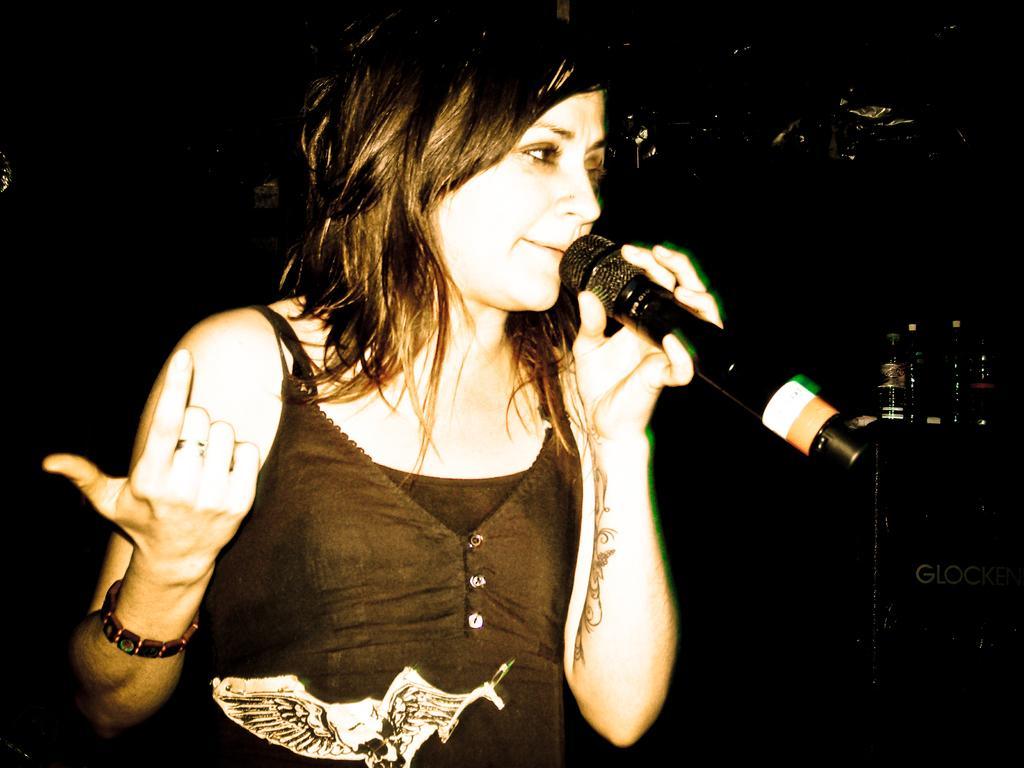How would you summarize this image in a sentence or two? As we can see in the image there is a woman holding mic. 